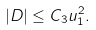Convert formula to latex. <formula><loc_0><loc_0><loc_500><loc_500>| D | \leq C _ { 3 } u _ { 1 } ^ { 2 } .</formula> 